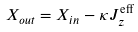<formula> <loc_0><loc_0><loc_500><loc_500>X _ { o u t } = X _ { i n } - \kappa J _ { z } ^ { \text {eff} }</formula> 